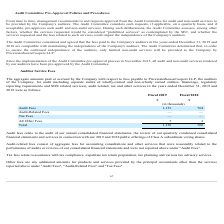From Shopify's financial document, Which financial years' information is shown in the table? The document shows two values: 2018 and 2019. From the document: "Fiscal 2019 Fiscal 2018 Fiscal 2019 Fiscal 2018..." Also, Which financial items are listed in the table? The document contains multiple relevant values: Audit Fees, Audit-Related Fees, Tax Fees, All Other Fees. From the document: "Audit Fees 1,133 764 Audit-Related Fees — — Tax Fees — — All Other Fees 3 2..." Also, What is the audit fees for fiscal 2019? According to the financial document, 1,133 (in thousands). The relevant text states: "Audit Fees 1,133 764..." Also, can you calculate: What is the average audit fees for 2018 and 2019? To answer this question, I need to perform calculations using the financial data. The calculation is: (1,133+764)/2, which equals 948.5 (in thousands). This is based on the information: "Audit Fees 1,133 764 Audit Fees 1,133 764..." The key data points involved are: 1,133, 764. Also, can you calculate: What is the average total auditor service fees for 2018 and 2019? To answer this question, I need to perform calculations using the financial data. The calculation is: (1,136+766)/2, which equals 951 (in thousands). This is based on the information: "Total 1,136 766 Total 1,136 766..." The key data points involved are: 1,136, 766. Additionally, Between fiscal 2018 and 2019, which year had higher audit fees? According to the financial document, 2019. The relevant text states: "Fiscal 2019 Fiscal 2018..." 